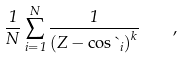Convert formula to latex. <formula><loc_0><loc_0><loc_500><loc_500>\frac { 1 } { N } \sum _ { i = 1 } ^ { N } { \frac { 1 } { \left ( Z - \cos { \theta _ { i } } \right ) ^ { k } } } \quad ,</formula> 